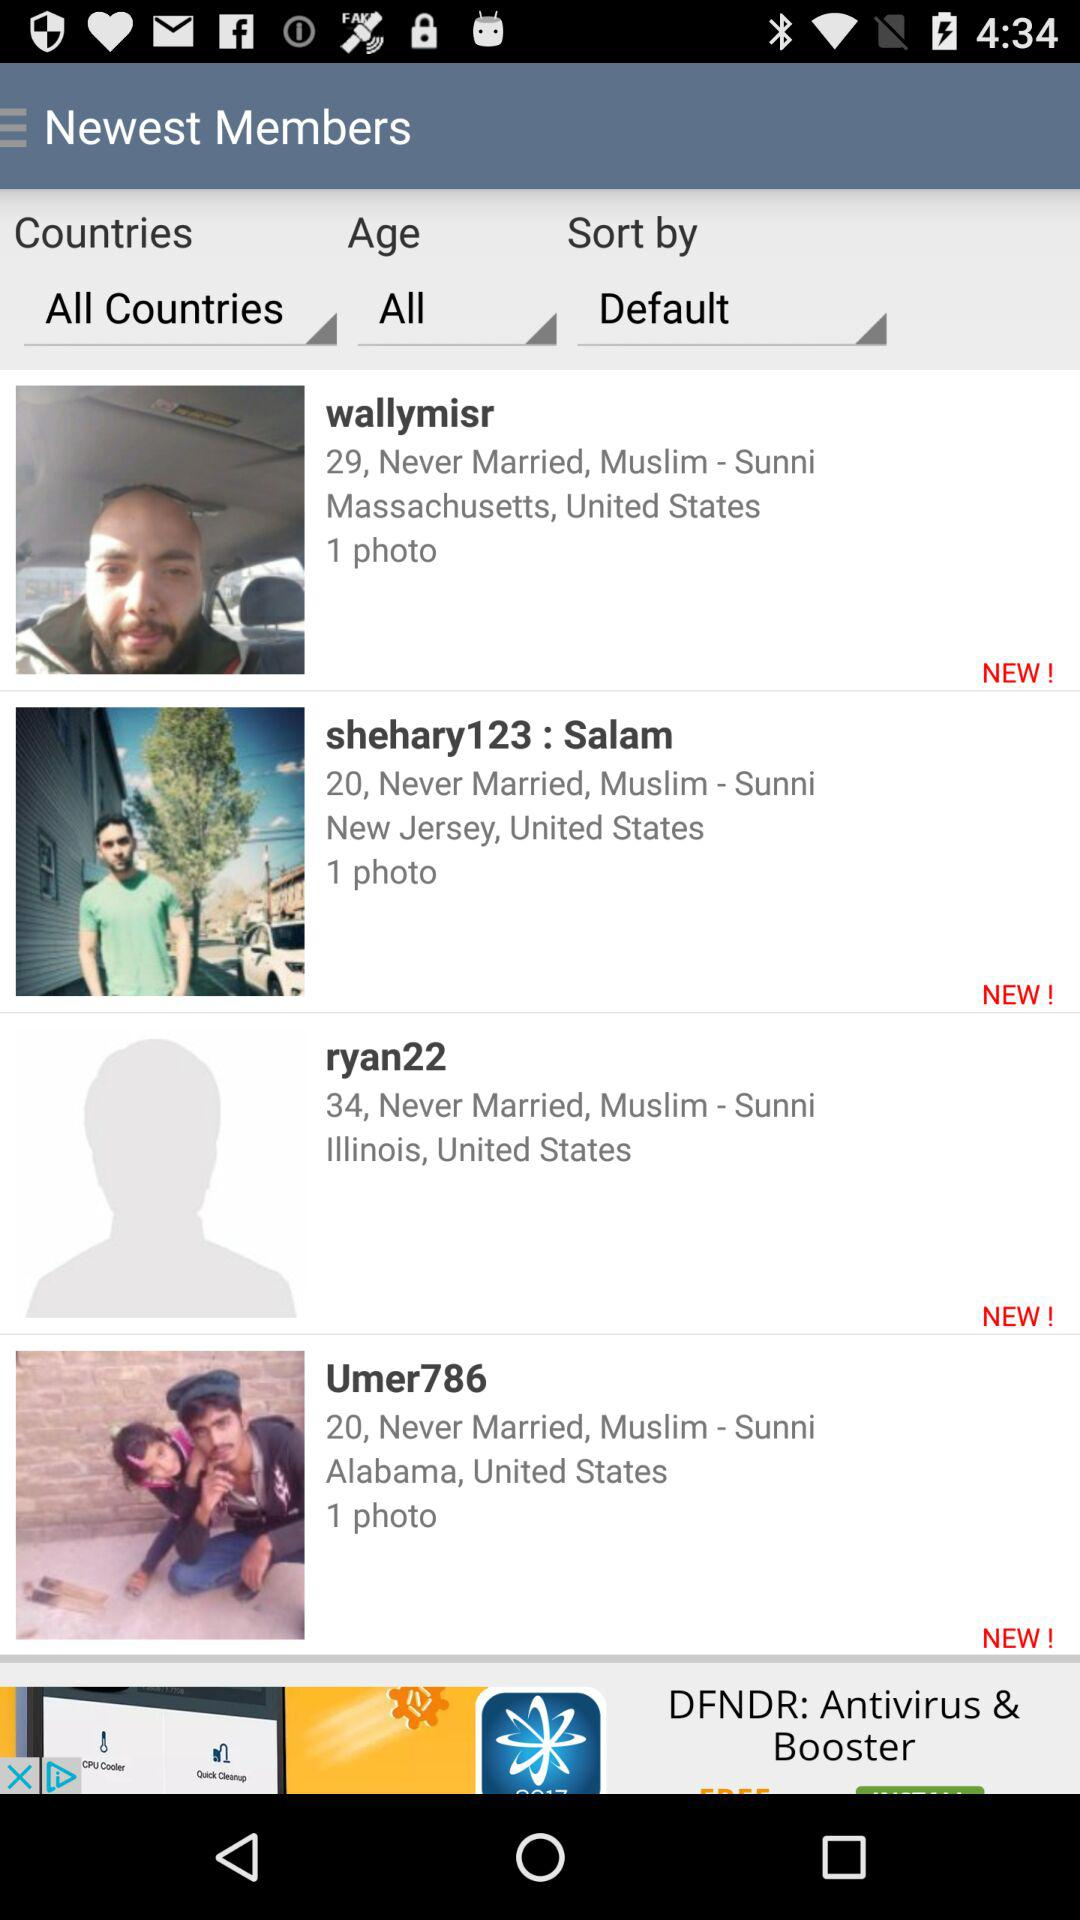What is the location of "Umer786"? The location is Alabama, United States. 